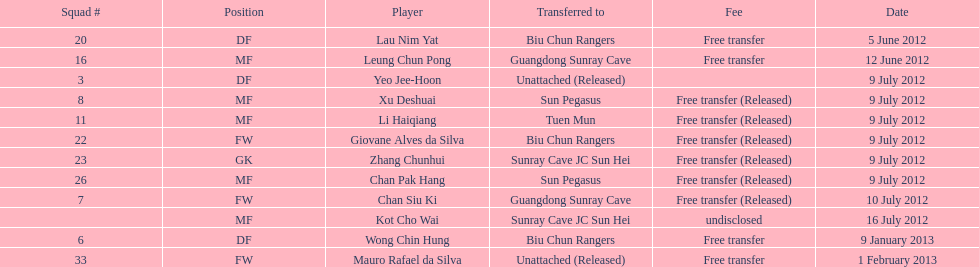Who is the foremost player listed? Lau Nim Yat. 